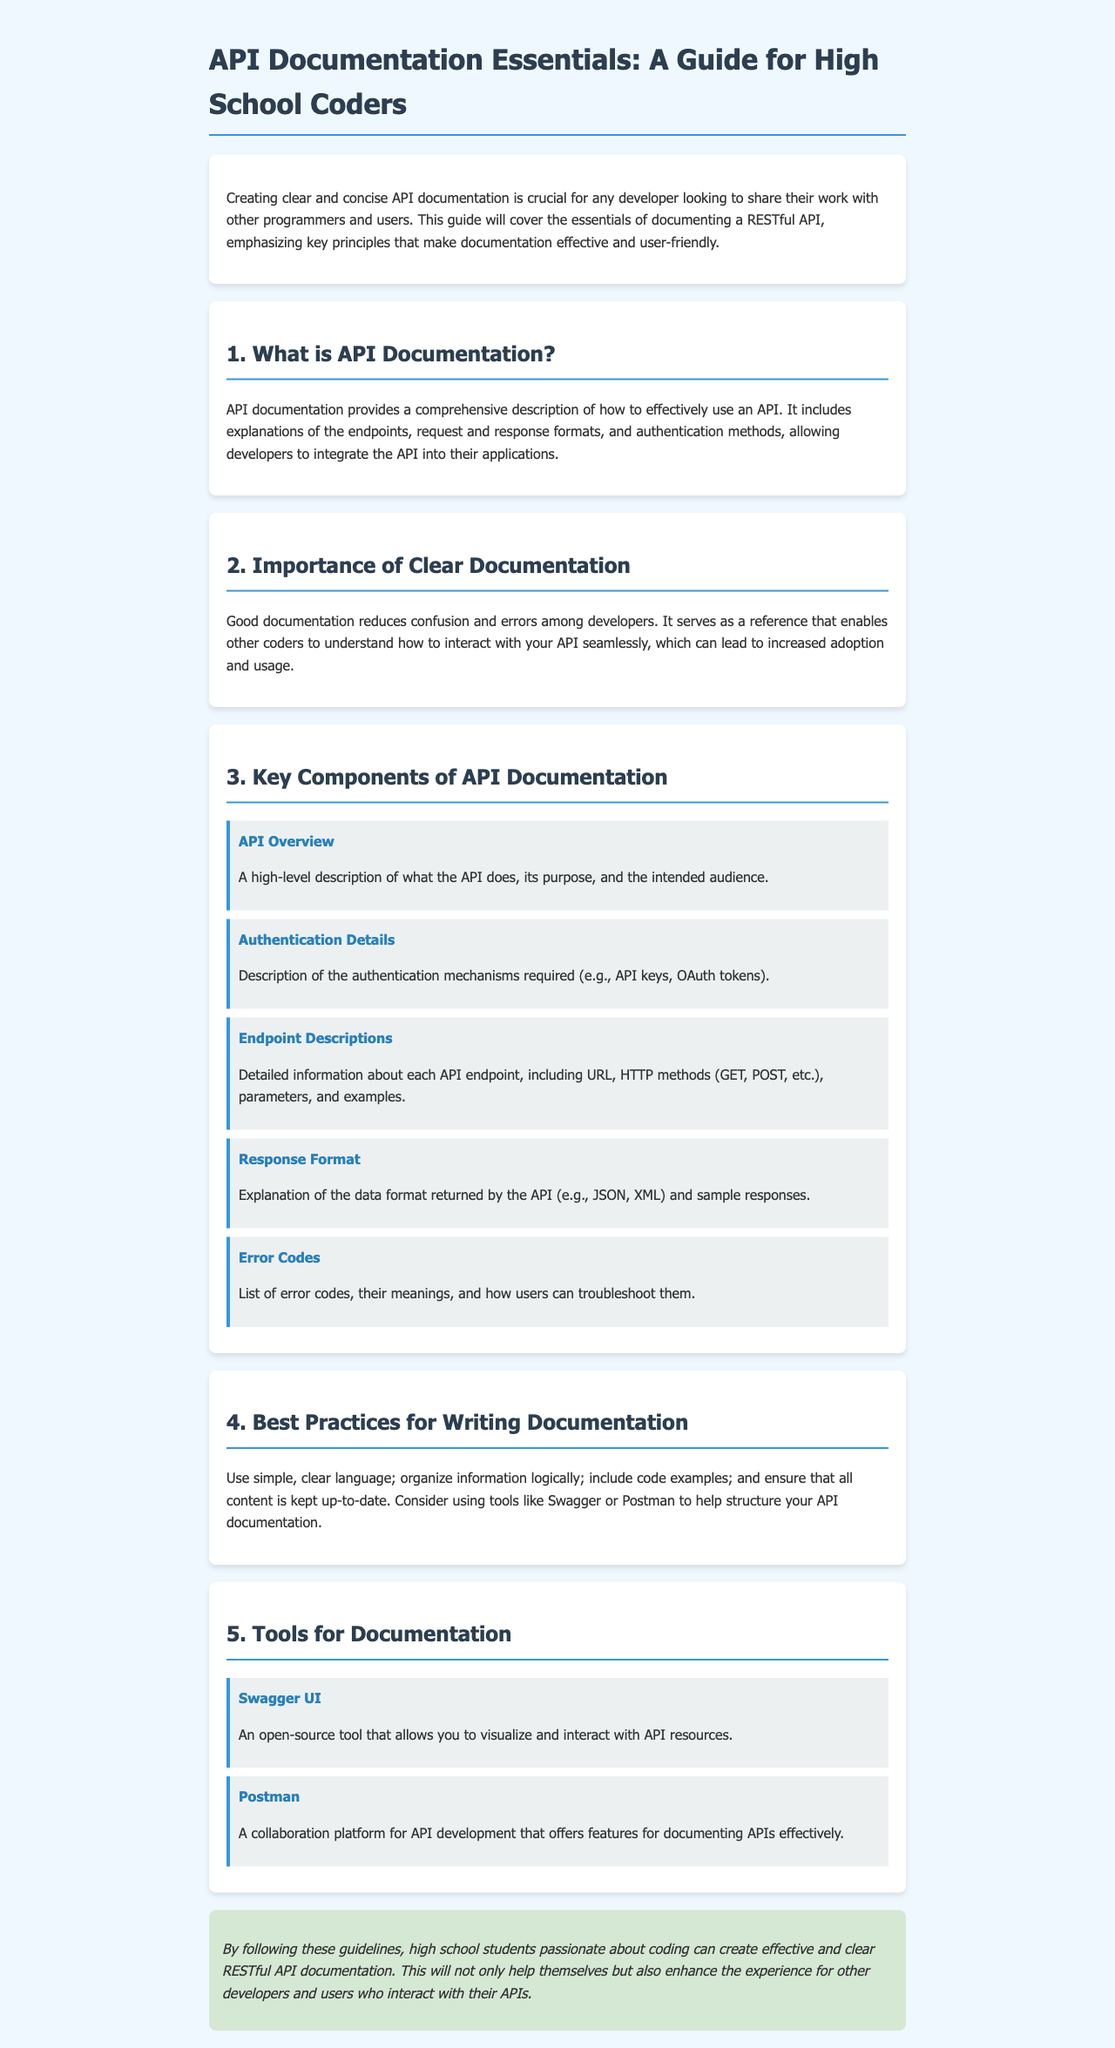What is the title of the guide? The title is given in the header of the document, which emphasizes the essential nature of the guide for high school coders.
Answer: API Documentation Essentials: A Guide for High School Coders Why is clear documentation important? The section on the importance of clear documentation explains its role in reducing confusion and errors among developers.
Answer: Reduces confusion and errors What are the key components of API documentation? The main section outlines various components that are essential for effective API documentation.
Answer: API Overview, Authentication Details, Endpoint Descriptions, Response Format, Error Codes What does Swagger UI allow you to do? This tool is mentioned in the documentation, highlighting its functionality for API visualization and interaction.
Answer: Visualize and interact with API resources What is the recommended tool for API documentation collaboration? The document lists tools available for documentation, specifically mentioning one that focuses on collaboration.
Answer: Postman How many key components are listed in the document? The document explicitly states the number of key components of API documentation that are discussed in detail.
Answer: Five What should you consider when writing documentation? The best practices section provides specific guidance on what to consider while writing effective documentation.
Answer: Use simple, clear language What is an example of an authentication mechanism? The authentication details component provides examples of methods required to access an API.
Answer: API keys What is included in endpoint descriptions? This component describes what detailed information is necessary to document each API endpoint effectively.
Answer: URL, HTTP methods, parameters, and examples 